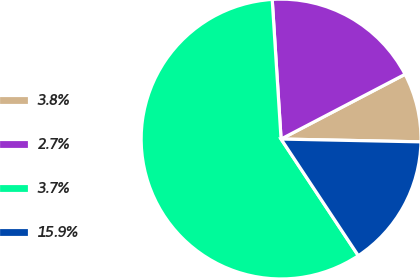<chart> <loc_0><loc_0><loc_500><loc_500><pie_chart><fcel>3.8%<fcel>2.7%<fcel>3.7%<fcel>15.9%<nl><fcel>7.98%<fcel>18.35%<fcel>58.3%<fcel>15.37%<nl></chart> 